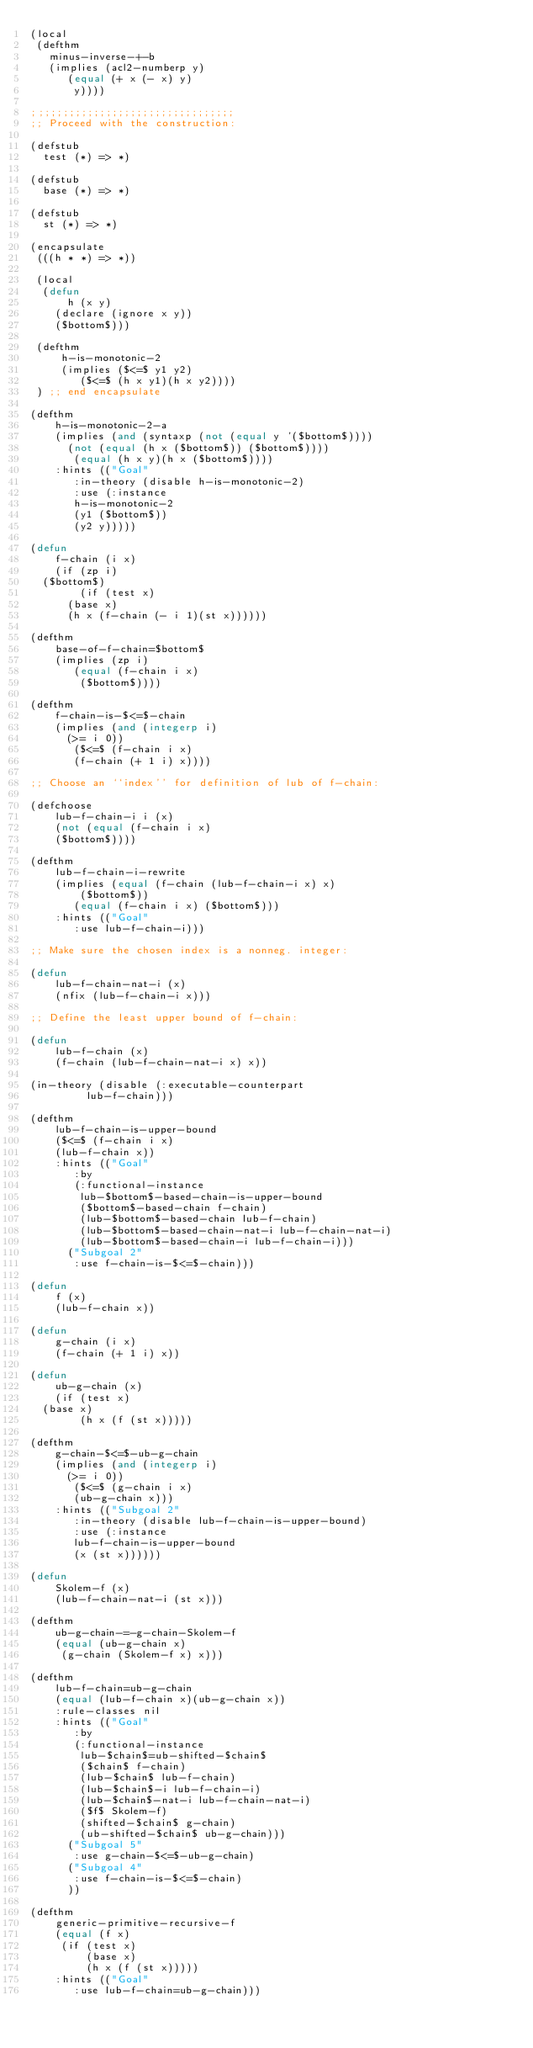Convert code to text. <code><loc_0><loc_0><loc_500><loc_500><_Lisp_>(local
 (defthm
   minus-inverse-+-b
   (implies (acl2-numberp y)
	    (equal (+ x (- x) y)
		   y))))

;;;;;;;;;;;;;;;;;;;;;;;;;;;;;;;;;
;; Proceed with the construction:

(defstub
  test (*) => *)

(defstub
  base (*) => *)

(defstub
  st (*) => *)

(encapsulate
 (((h * *) => *))

 (local
  (defun
      h (x y)
    (declare (ignore x y))
    ($bottom$)))

 (defthm
     h-is-monotonic-2
     (implies ($<=$ y1 y2)
	      ($<=$ (h x y1)(h x y2))))
 ) ;; end encapsulate

(defthm
    h-is-monotonic-2-a
    (implies (and (syntaxp (not (equal y '($bottom$))))
		  (not (equal (h x ($bottom$)) ($bottom$))))
	     (equal (h x y)(h x ($bottom$))))
    :hints (("Goal"
	     :in-theory (disable h-is-monotonic-2)
	     :use (:instance
		   h-is-monotonic-2
		   (y1 ($bottom$))
		   (y2 y)))))

(defun
    f-chain (i x)
    (if (zp i)
	($bottom$)
        (if (test x)
	    (base x)
	    (h x (f-chain (- i 1)(st x))))))

(defthm
    base-of-f-chain=$bottom$
    (implies (zp i)
	     (equal (f-chain i x)
		    ($bottom$))))

(defthm
    f-chain-is-$<=$-chain
    (implies (and (integerp i)
		  (>= i 0))
	     ($<=$ (f-chain i x)
		   (f-chain (+ 1 i) x))))

;; Choose an ``index'' for definition of lub of f-chain:

(defchoose
    lub-f-chain-i i (x)
    (not (equal (f-chain i x)
		($bottom$))))

(defthm
    lub-f-chain-i-rewrite
    (implies (equal (f-chain (lub-f-chain-i x) x)
		    ($bottom$))
	     (equal (f-chain i x) ($bottom$)))
    :hints (("Goal"
	     :use lub-f-chain-i)))

;; Make sure the chosen index is a nonneg. integer:

(defun
    lub-f-chain-nat-i (x)
    (nfix (lub-f-chain-i x)))

;; Define the least upper bound of f-chain:

(defun
    lub-f-chain (x)
    (f-chain (lub-f-chain-nat-i x) x))

(in-theory (disable (:executable-counterpart
		     lub-f-chain)))

(defthm
    lub-f-chain-is-upper-bound
    ($<=$ (f-chain i x)
	  (lub-f-chain x))
    :hints (("Goal"
	     :by
	     (:functional-instance
	      lub-$bottom$-based-chain-is-upper-bound
	      ($bottom$-based-chain f-chain)
	      (lub-$bottom$-based-chain lub-f-chain)
	      (lub-$bottom$-based-chain-nat-i lub-f-chain-nat-i)
	      (lub-$bottom$-based-chain-i lub-f-chain-i)))
	    ("Subgoal 2"
	     :use f-chain-is-$<=$-chain)))

(defun
    f (x)
    (lub-f-chain x))

(defun
    g-chain (i x)
    (f-chain (+ 1 i) x))

(defun
    ub-g-chain (x)
    (if (test x)
	(base x)
        (h x (f (st x)))))

(defthm
    g-chain-$<=$-ub-g-chain
    (implies (and (integerp i)
		  (>= i 0))
	     ($<=$ (g-chain i x)
		   (ub-g-chain x)))
    :hints (("Subgoal 2"
	     :in-theory (disable lub-f-chain-is-upper-bound)
	     :use (:instance
		   lub-f-chain-is-upper-bound
		   (x (st x))))))

(defun
    Skolem-f (x)
    (lub-f-chain-nat-i (st x)))

(defthm
    ub-g-chain-=-g-chain-Skolem-f
    (equal (ub-g-chain x)
	   (g-chain (Skolem-f x) x)))

(defthm
    lub-f-chain=ub-g-chain
    (equal (lub-f-chain x)(ub-g-chain x))
    :rule-classes nil
    :hints (("Goal"
	     :by
	     (:functional-instance
	      lub-$chain$=ub-shifted-$chain$
	      ($chain$ f-chain)
	      (lub-$chain$ lub-f-chain)
	      (lub-$chain$-i lub-f-chain-i)
	      (lub-$chain$-nat-i lub-f-chain-nat-i)
	      ($f$ Skolem-f)
	      (shifted-$chain$ g-chain)
	      (ub-shifted-$chain$ ub-g-chain)))
	    ("Subgoal 5"
	     :use g-chain-$<=$-ub-g-chain)
	    ("Subgoal 4"
	     :use f-chain-is-$<=$-chain)
	    ))

(defthm
    generic-primitive-recursive-f
    (equal (f x)
	   (if (test x)
	       (base x)
	       (h x (f (st x)))))
    :hints (("Goal"
	     :use lub-f-chain=ub-g-chain)))
</code> 